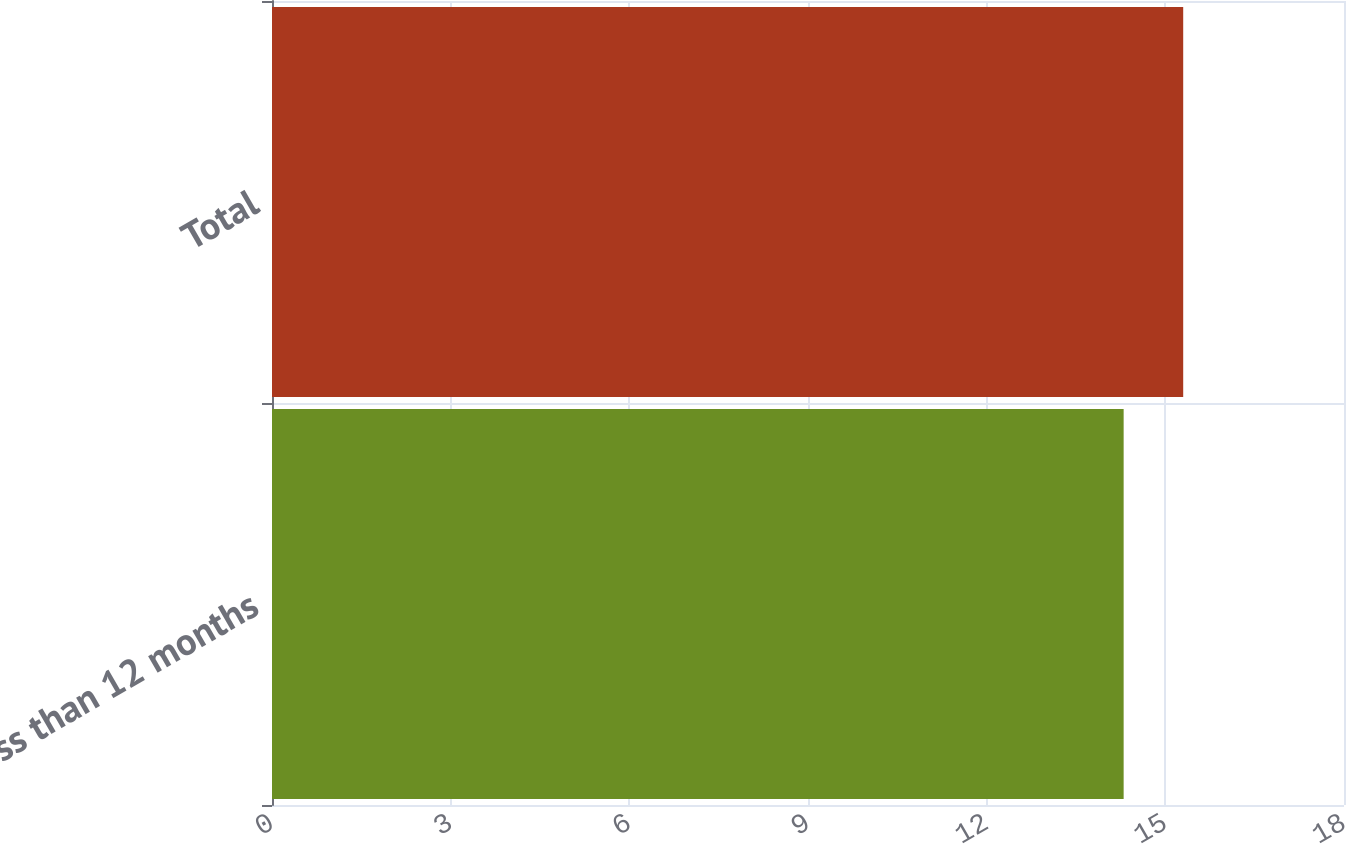Convert chart to OTSL. <chart><loc_0><loc_0><loc_500><loc_500><bar_chart><fcel>Less than 12 months<fcel>Total<nl><fcel>14.3<fcel>15.3<nl></chart> 